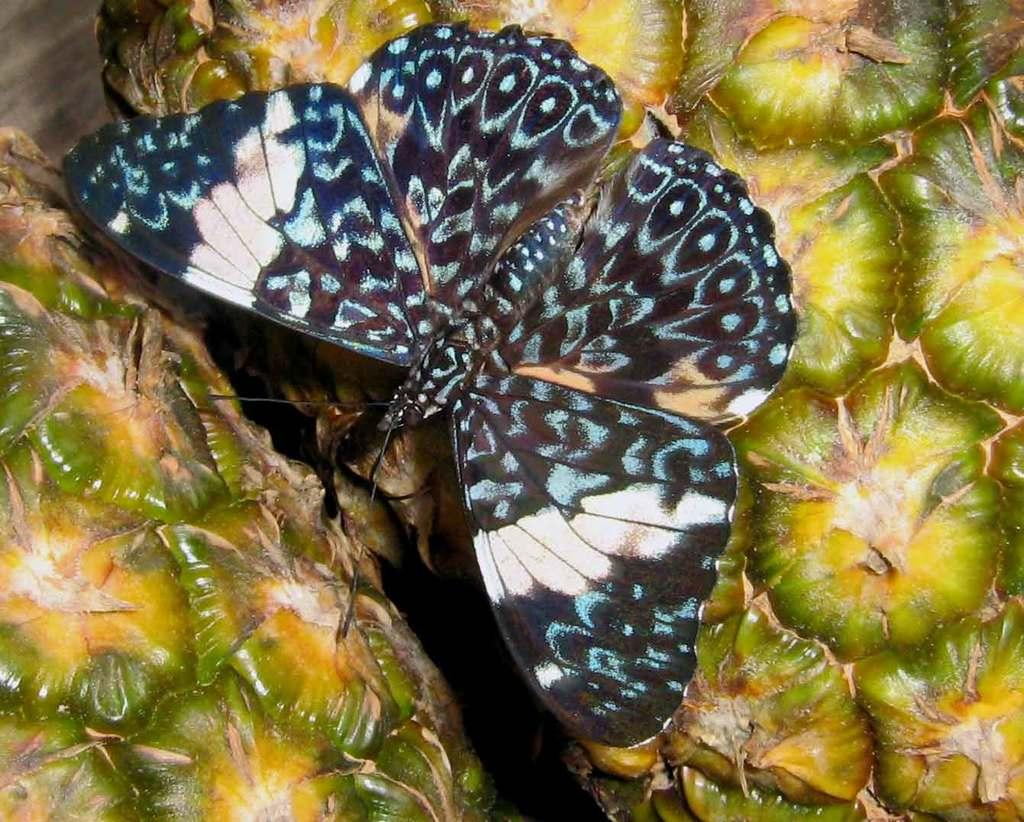What is the main subject of the image? The main subject of the image is a butterfly. What is the butterfly resting on? The butterfly is on a pineapple. Where is the butterfly and pineapple located in the image? The butterfly and pineapple are in the center of the image. How many fans can be seen in the image? There are no fans present in the image. What type of bears are interacting with the pineapple in the image? There are no bears present in the image. 